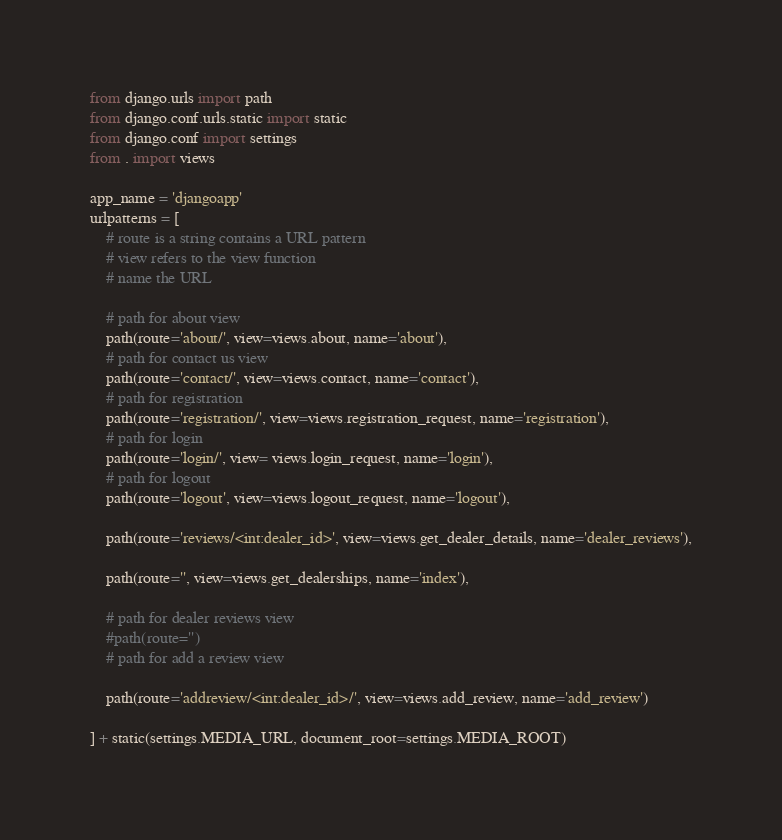Convert code to text. <code><loc_0><loc_0><loc_500><loc_500><_Python_>from django.urls import path
from django.conf.urls.static import static
from django.conf import settings
from . import views

app_name = 'djangoapp'
urlpatterns = [
    # route is a string contains a URL pattern
    # view refers to the view function
    # name the URL

    # path for about view
    path(route='about/', view=views.about, name='about'),
    # path for contact us view
    path(route='contact/', view=views.contact, name='contact'),
    # path for registration
    path(route='registration/', view=views.registration_request, name='registration'),
    # path for login
    path(route='login/', view= views.login_request, name='login'),
    # path for logout
    path(route='logout', view=views.logout_request, name='logout'),

    path(route='reviews/<int:dealer_id>', view=views.get_dealer_details, name='dealer_reviews'),

    path(route='', view=views.get_dealerships, name='index'),

    # path for dealer reviews view
    #path(route='')
    # path for add a review view

    path(route='addreview/<int:dealer_id>/', view=views.add_review, name='add_review')

] + static(settings.MEDIA_URL, document_root=settings.MEDIA_ROOT)</code> 